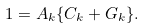Convert formula to latex. <formula><loc_0><loc_0><loc_500><loc_500>1 = A _ { k } \{ C _ { k } + G _ { k } \} .</formula> 